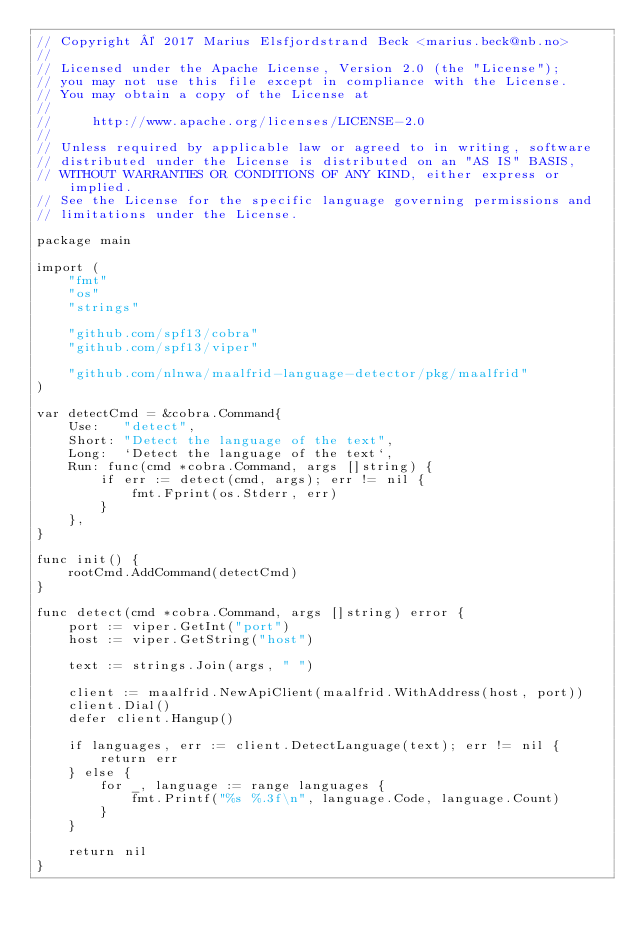<code> <loc_0><loc_0><loc_500><loc_500><_Go_>// Copyright © 2017 Marius Elsfjordstrand Beck <marius.beck@nb.no>
//
// Licensed under the Apache License, Version 2.0 (the "License");
// you may not use this file except in compliance with the License.
// You may obtain a copy of the License at
//
//     http://www.apache.org/licenses/LICENSE-2.0
//
// Unless required by applicable law or agreed to in writing, software
// distributed under the License is distributed on an "AS IS" BASIS,
// WITHOUT WARRANTIES OR CONDITIONS OF ANY KIND, either express or implied.
// See the License for the specific language governing permissions and
// limitations under the License.

package main

import (
	"fmt"
	"os"
	"strings"

	"github.com/spf13/cobra"
	"github.com/spf13/viper"

	"github.com/nlnwa/maalfrid-language-detector/pkg/maalfrid"
)

var detectCmd = &cobra.Command{
	Use:   "detect",
	Short: "Detect the language of the text",
	Long:  `Detect the language of the text`,
	Run: func(cmd *cobra.Command, args []string) {
		if err := detect(cmd, args); err != nil {
			fmt.Fprint(os.Stderr, err)
		}
	},
}

func init() {
	rootCmd.AddCommand(detectCmd)
}

func detect(cmd *cobra.Command, args []string) error {
	port := viper.GetInt("port")
	host := viper.GetString("host")

	text := strings.Join(args, " ")

	client := maalfrid.NewApiClient(maalfrid.WithAddress(host, port))
	client.Dial()
	defer client.Hangup()

	if languages, err := client.DetectLanguage(text); err != nil {
		return err
	} else {
		for _, language := range languages {
			fmt.Printf("%s %.3f\n", language.Code, language.Count)
		}
	}

	return nil
}
</code> 